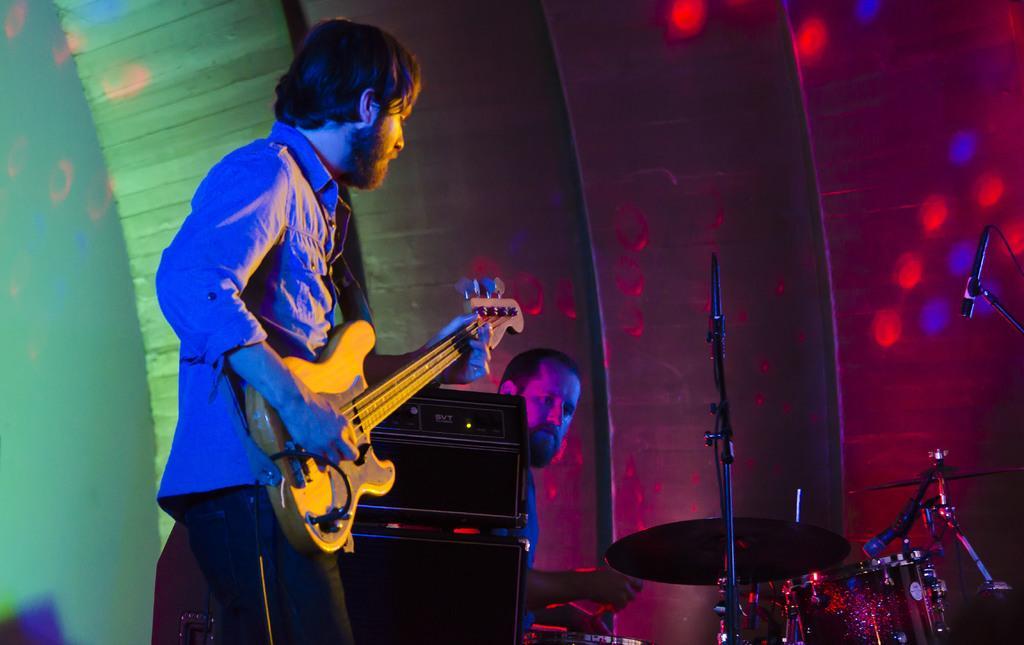Describe this image in one or two sentences. A man is standing and playing a guitar. There is a speaker beside him. Beside the speaker there is a man playing drums. Colorful lights flashed to the wall behind. 